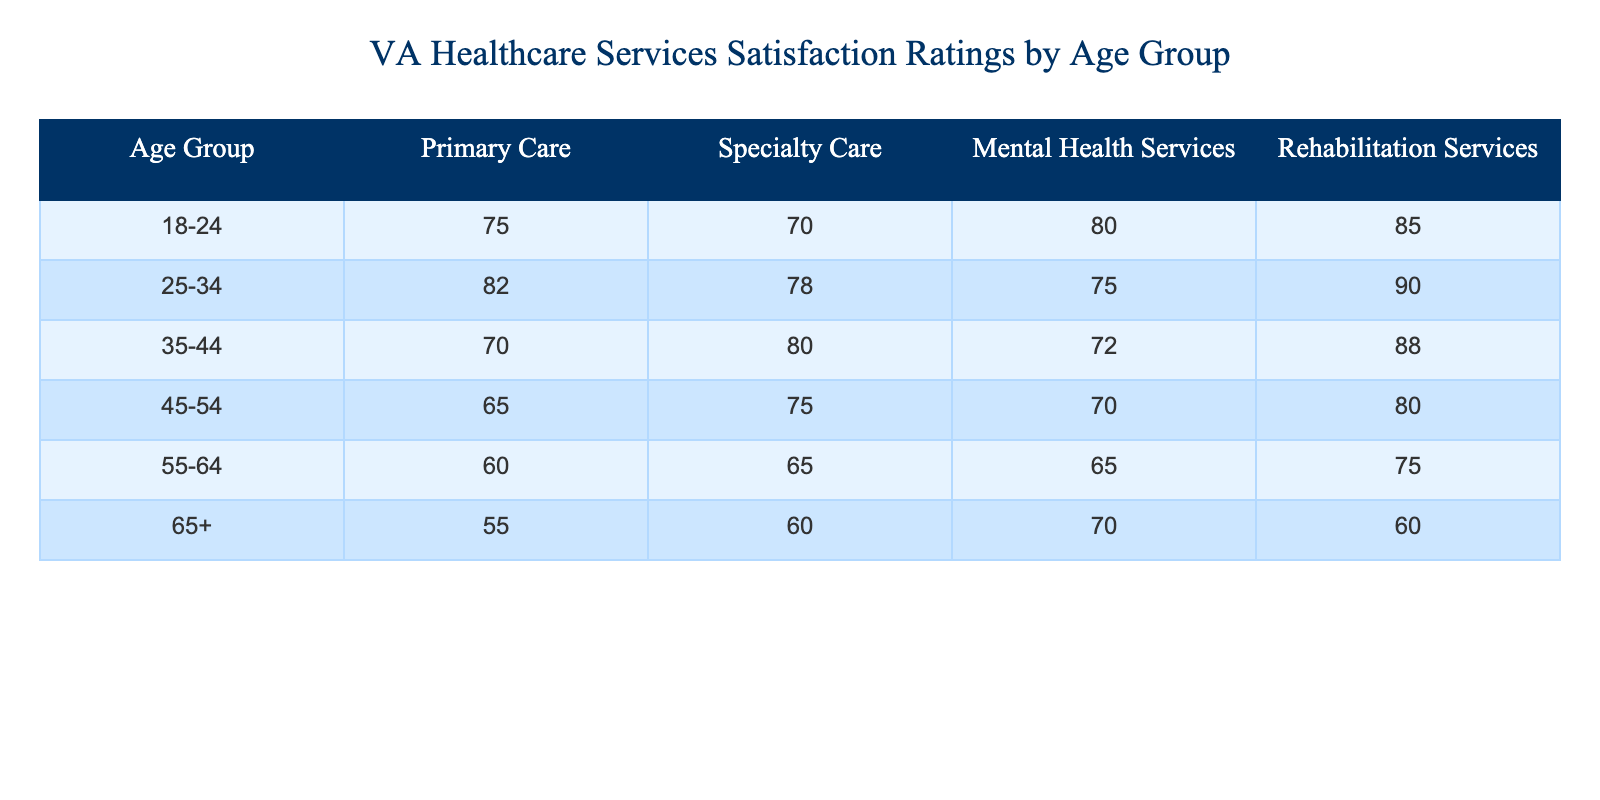What is the satisfaction rating for Primary Care in the age group 25-34? Referring to the table, the satisfaction rating for Primary Care in the age group 25-34 is directly listed as 82.
Answer: 82 Which age group reported the highest satisfaction rating for Mental Health Services? In the table, the age group 18-24 shows a satisfaction rating of 80 for Mental Health Services, which is the highest compared to other age groups.
Answer: 18-24 What is the average satisfaction rating for Rehabilitation Services across all age groups? To find the average, sum the ratings for Rehabilitation Services across all age groups: (85 + 90 + 88 + 80 + 75 + 60) = 478. There are 6 age groups, so the average is 478 / 6 = 79.67, which can be rounded to 80.
Answer: 80 Is the satisfaction rating for Specialty Care in the age group 65+ higher than that in the age group 55-64? The table shows that the satisfaction rating for Specialty Care in the age group 65+ is 60, while in the age group 55-64, it is 65. Since 60 is not higher than 65, the statement is false.
Answer: No What is the difference in satisfaction ratings for Rehabilitation Services between the age groups 45-54 and 65+? The satisfaction rating for Rehabilitation Services in the age group 45-54 is 80, while for 65+, it is 60. The difference is 80 - 60 = 20.
Answer: 20 Which age group has the lowest satisfaction rating in Primary Care and what is that rating? The table indicates that the age group 65+ has the lowest rating for Primary Care, which is 55—the lowest value in that column.
Answer: 65+ with a rating of 55 What is the total satisfaction rating for Mental Health Services from all age groups combined? Adding the satisfaction ratings for all age groups for Mental Health Services: 80 + 75 + 72 + 70 + 65 + 70 = 432.
Answer: 432 Are satisfaction ratings for Rehabilitation Services consistently above 75 for all age groups? By examining the table, the ratings for Rehabilitation Services are 85, 90, 88, 80, 75, and 60 across the age groups. Since the last rating (60) is below 75, the statement is false.
Answer: No 